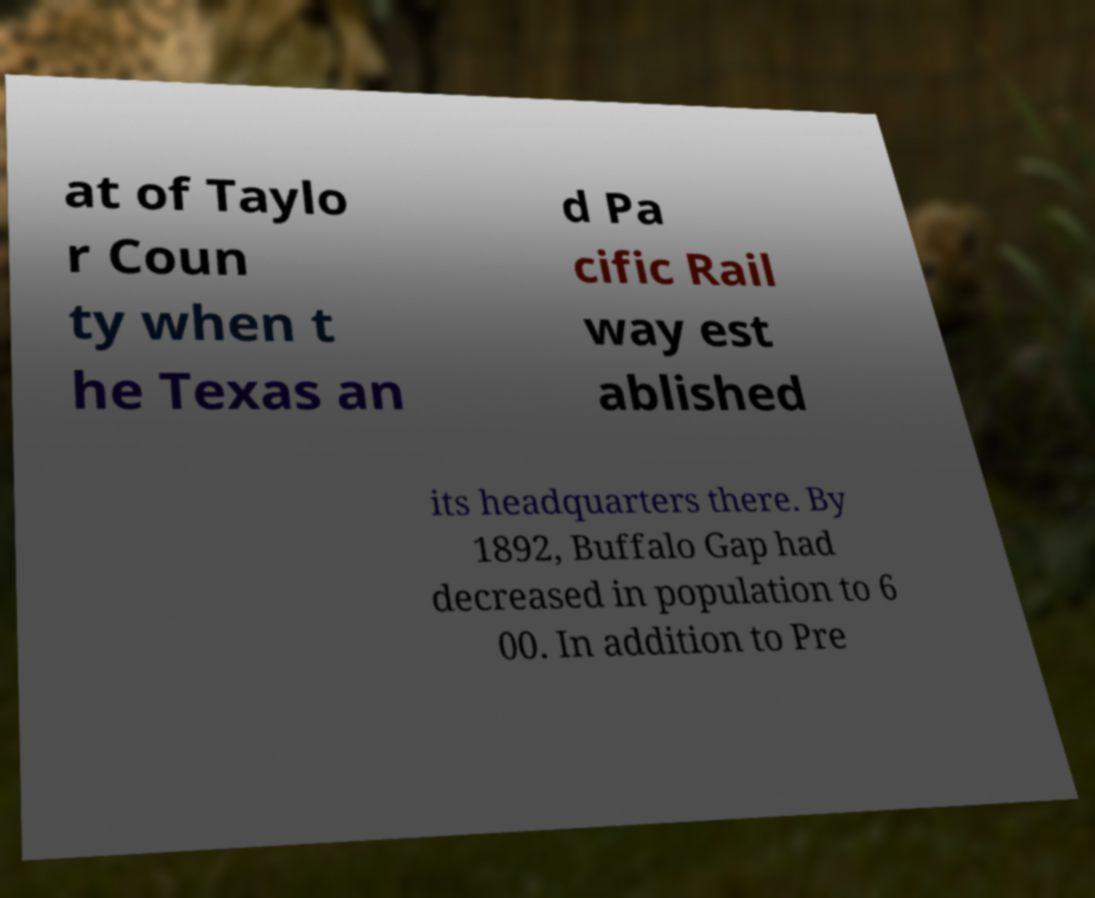Could you assist in decoding the text presented in this image and type it out clearly? at of Taylo r Coun ty when t he Texas an d Pa cific Rail way est ablished its headquarters there. By 1892, Buffalo Gap had decreased in population to 6 00. In addition to Pre 